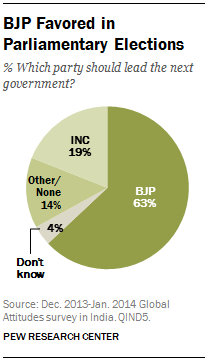List a handful of essential elements in this visual. The percentage of votes received by the BJP is 63%. The median of all the segments is less than the sum of the two smallest segments. 